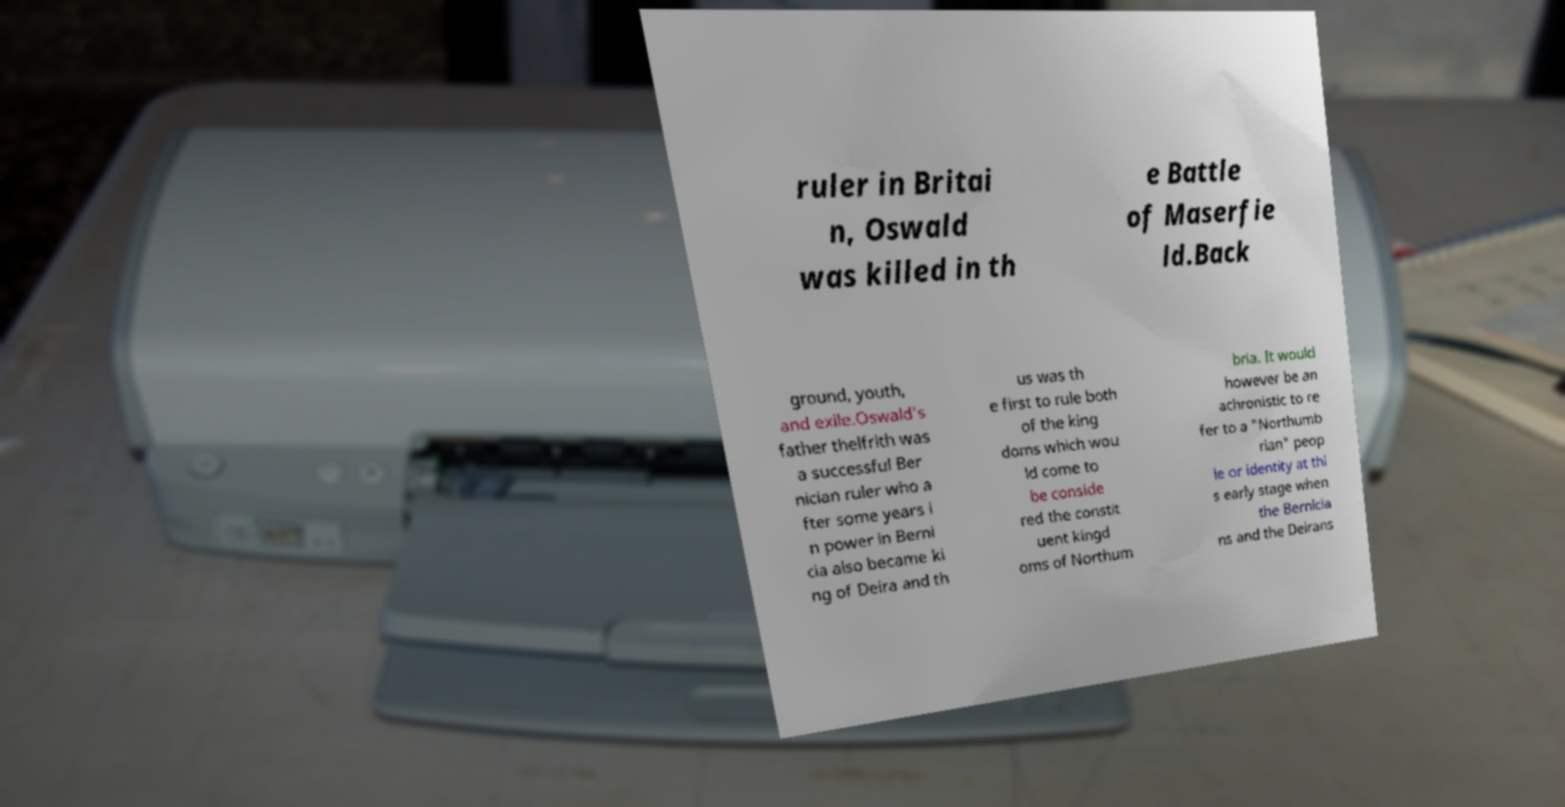Could you extract and type out the text from this image? ruler in Britai n, Oswald was killed in th e Battle of Maserfie ld.Back ground, youth, and exile.Oswald's father thelfrith was a successful Ber nician ruler who a fter some years i n power in Berni cia also became ki ng of Deira and th us was th e first to rule both of the king doms which wou ld come to be conside red the constit uent kingd oms of Northum bria. It would however be an achronistic to re fer to a "Northumb rian" peop le or identity at thi s early stage when the Bernicia ns and the Deirans 